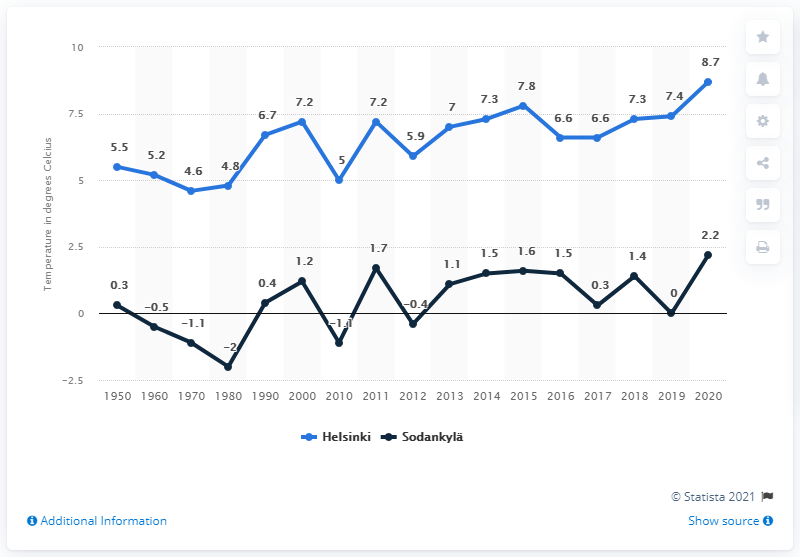List a handful of essential elements in this visual. The average annual temperature in Sodankylä fell to -2 degrees Celsius in 1980. 